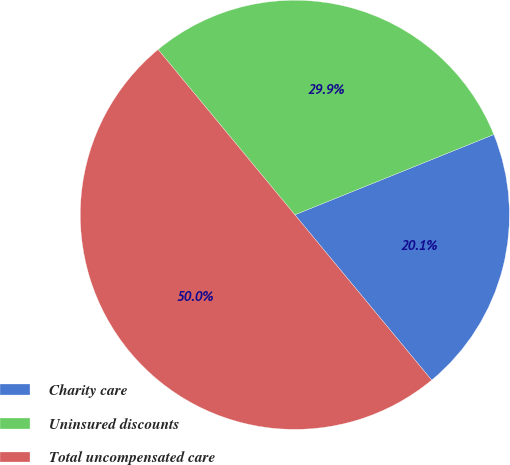<chart> <loc_0><loc_0><loc_500><loc_500><pie_chart><fcel>Charity care<fcel>Uninsured discounts<fcel>Total uncompensated care<nl><fcel>20.1%<fcel>29.9%<fcel>50.0%<nl></chart> 